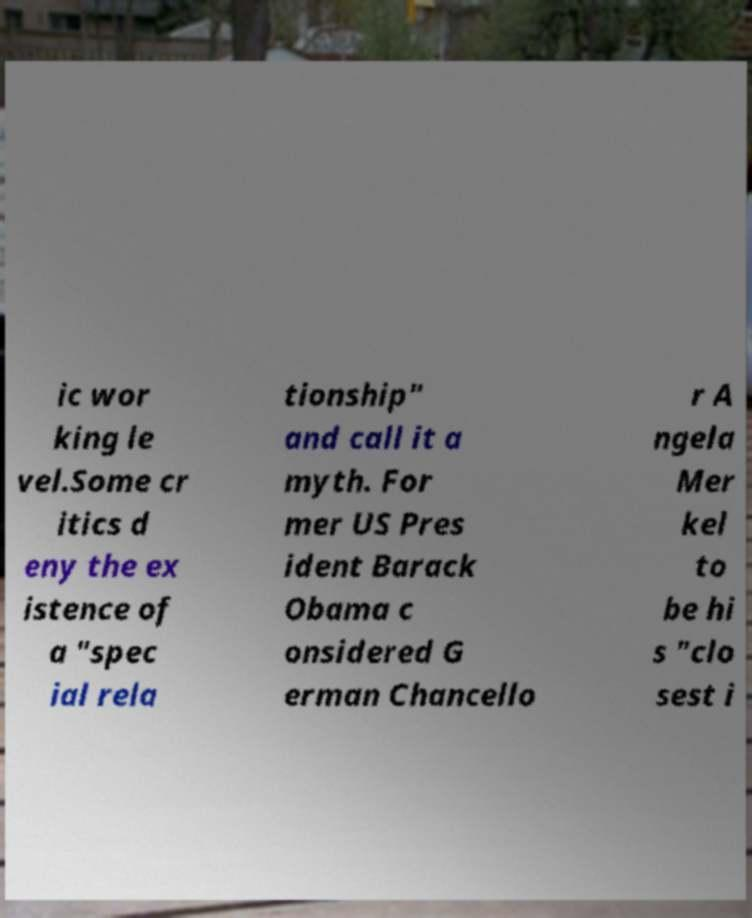Can you read and provide the text displayed in the image?This photo seems to have some interesting text. Can you extract and type it out for me? ic wor king le vel.Some cr itics d eny the ex istence of a "spec ial rela tionship" and call it a myth. For mer US Pres ident Barack Obama c onsidered G erman Chancello r A ngela Mer kel to be hi s "clo sest i 